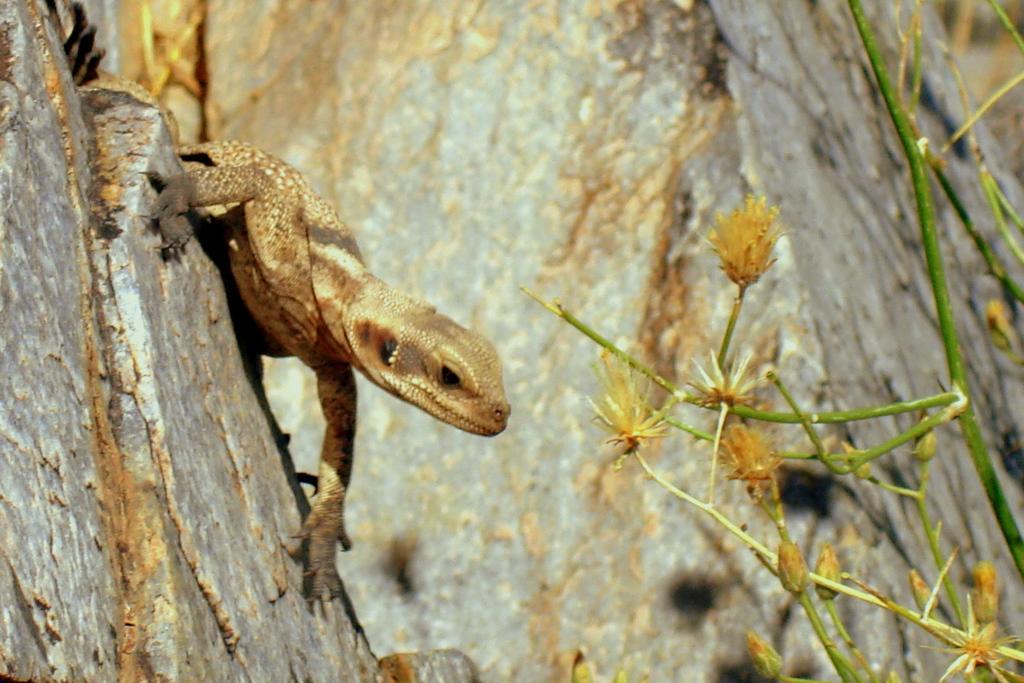In one or two sentences, can you explain what this image depicts? We can see reptile on the surface and we can see plant,flowers and buds. In the background we can see rock. 